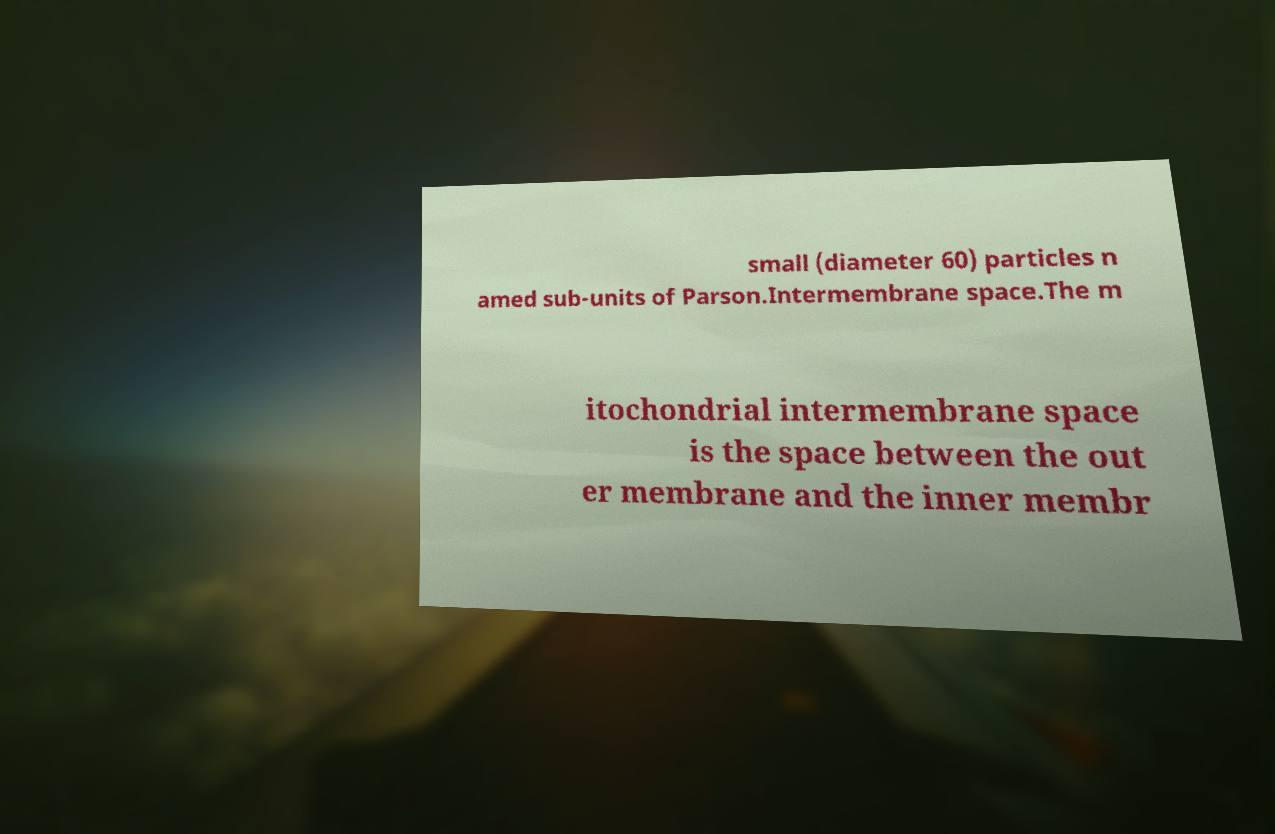Can you accurately transcribe the text from the provided image for me? small (diameter 60) particles n amed sub-units of Parson.Intermembrane space.The m itochondrial intermembrane space is the space between the out er membrane and the inner membr 